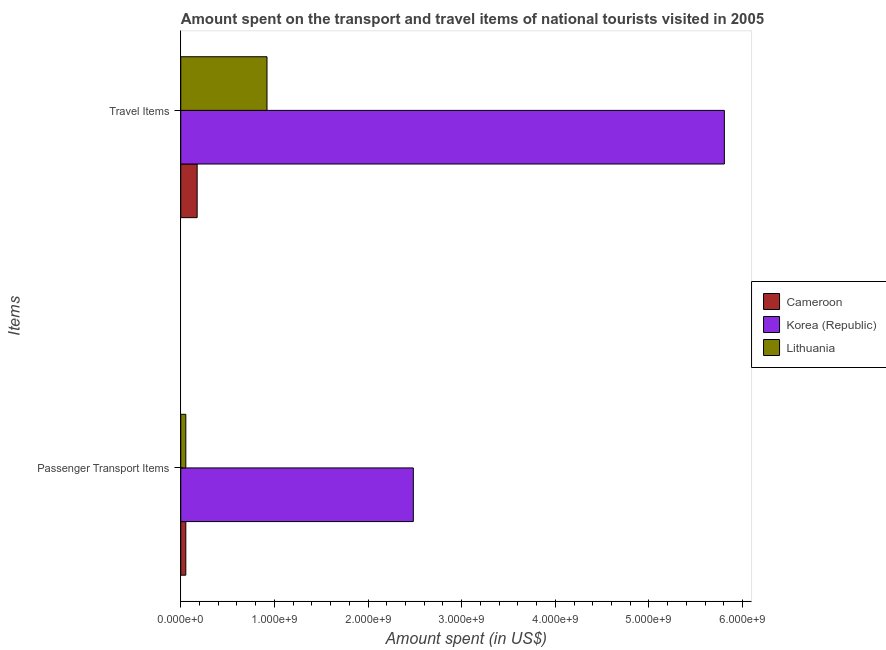How many different coloured bars are there?
Ensure brevity in your answer.  3. How many groups of bars are there?
Make the answer very short. 2. Are the number of bars on each tick of the Y-axis equal?
Keep it short and to the point. Yes. How many bars are there on the 2nd tick from the bottom?
Provide a short and direct response. 3. What is the label of the 1st group of bars from the top?
Provide a succinct answer. Travel Items. What is the amount spent on passenger transport items in Cameroon?
Your response must be concise. 5.40e+07. Across all countries, what is the maximum amount spent in travel items?
Ensure brevity in your answer.  5.81e+09. Across all countries, what is the minimum amount spent on passenger transport items?
Your answer should be compact. 5.40e+07. In which country was the amount spent on passenger transport items maximum?
Give a very brief answer. Korea (Republic). In which country was the amount spent on passenger transport items minimum?
Offer a very short reply. Cameroon. What is the total amount spent on passenger transport items in the graph?
Give a very brief answer. 2.59e+09. What is the difference between the amount spent in travel items in Cameroon and that in Lithuania?
Offer a terse response. -7.46e+08. What is the difference between the amount spent on passenger transport items in Lithuania and the amount spent in travel items in Cameroon?
Ensure brevity in your answer.  -1.21e+08. What is the average amount spent on passenger transport items per country?
Keep it short and to the point. 8.64e+08. What is the difference between the amount spent on passenger transport items and amount spent in travel items in Korea (Republic)?
Your answer should be very brief. -3.32e+09. What is the ratio of the amount spent on passenger transport items in Lithuania to that in Korea (Republic)?
Your answer should be compact. 0.02. In how many countries, is the amount spent on passenger transport items greater than the average amount spent on passenger transport items taken over all countries?
Your response must be concise. 1. What does the 1st bar from the top in Travel Items represents?
Give a very brief answer. Lithuania. What does the 1st bar from the bottom in Passenger Transport Items represents?
Your answer should be very brief. Cameroon. What is the difference between two consecutive major ticks on the X-axis?
Make the answer very short. 1.00e+09. Are the values on the major ticks of X-axis written in scientific E-notation?
Make the answer very short. Yes. Does the graph contain grids?
Give a very brief answer. No. How many legend labels are there?
Give a very brief answer. 3. How are the legend labels stacked?
Provide a short and direct response. Vertical. What is the title of the graph?
Give a very brief answer. Amount spent on the transport and travel items of national tourists visited in 2005. What is the label or title of the X-axis?
Provide a short and direct response. Amount spent (in US$). What is the label or title of the Y-axis?
Your answer should be compact. Items. What is the Amount spent (in US$) of Cameroon in Passenger Transport Items?
Offer a terse response. 5.40e+07. What is the Amount spent (in US$) in Korea (Republic) in Passenger Transport Items?
Make the answer very short. 2.48e+09. What is the Amount spent (in US$) of Lithuania in Passenger Transport Items?
Your answer should be very brief. 5.40e+07. What is the Amount spent (in US$) of Cameroon in Travel Items?
Provide a short and direct response. 1.75e+08. What is the Amount spent (in US$) in Korea (Republic) in Travel Items?
Offer a terse response. 5.81e+09. What is the Amount spent (in US$) of Lithuania in Travel Items?
Keep it short and to the point. 9.21e+08. Across all Items, what is the maximum Amount spent (in US$) in Cameroon?
Keep it short and to the point. 1.75e+08. Across all Items, what is the maximum Amount spent (in US$) of Korea (Republic)?
Your answer should be compact. 5.81e+09. Across all Items, what is the maximum Amount spent (in US$) of Lithuania?
Provide a succinct answer. 9.21e+08. Across all Items, what is the minimum Amount spent (in US$) in Cameroon?
Offer a terse response. 5.40e+07. Across all Items, what is the minimum Amount spent (in US$) of Korea (Republic)?
Your response must be concise. 2.48e+09. Across all Items, what is the minimum Amount spent (in US$) in Lithuania?
Give a very brief answer. 5.40e+07. What is the total Amount spent (in US$) in Cameroon in the graph?
Offer a very short reply. 2.29e+08. What is the total Amount spent (in US$) of Korea (Republic) in the graph?
Your answer should be compact. 8.29e+09. What is the total Amount spent (in US$) in Lithuania in the graph?
Offer a very short reply. 9.75e+08. What is the difference between the Amount spent (in US$) of Cameroon in Passenger Transport Items and that in Travel Items?
Your answer should be very brief. -1.21e+08. What is the difference between the Amount spent (in US$) of Korea (Republic) in Passenger Transport Items and that in Travel Items?
Your answer should be very brief. -3.32e+09. What is the difference between the Amount spent (in US$) in Lithuania in Passenger Transport Items and that in Travel Items?
Offer a terse response. -8.67e+08. What is the difference between the Amount spent (in US$) in Cameroon in Passenger Transport Items and the Amount spent (in US$) in Korea (Republic) in Travel Items?
Keep it short and to the point. -5.75e+09. What is the difference between the Amount spent (in US$) in Cameroon in Passenger Transport Items and the Amount spent (in US$) in Lithuania in Travel Items?
Your response must be concise. -8.67e+08. What is the difference between the Amount spent (in US$) in Korea (Republic) in Passenger Transport Items and the Amount spent (in US$) in Lithuania in Travel Items?
Offer a terse response. 1.56e+09. What is the average Amount spent (in US$) in Cameroon per Items?
Offer a very short reply. 1.14e+08. What is the average Amount spent (in US$) of Korea (Republic) per Items?
Make the answer very short. 4.14e+09. What is the average Amount spent (in US$) in Lithuania per Items?
Offer a terse response. 4.88e+08. What is the difference between the Amount spent (in US$) of Cameroon and Amount spent (in US$) of Korea (Republic) in Passenger Transport Items?
Give a very brief answer. -2.43e+09. What is the difference between the Amount spent (in US$) in Cameroon and Amount spent (in US$) in Lithuania in Passenger Transport Items?
Ensure brevity in your answer.  0. What is the difference between the Amount spent (in US$) in Korea (Republic) and Amount spent (in US$) in Lithuania in Passenger Transport Items?
Ensure brevity in your answer.  2.43e+09. What is the difference between the Amount spent (in US$) in Cameroon and Amount spent (in US$) in Korea (Republic) in Travel Items?
Your answer should be very brief. -5.63e+09. What is the difference between the Amount spent (in US$) of Cameroon and Amount spent (in US$) of Lithuania in Travel Items?
Provide a short and direct response. -7.46e+08. What is the difference between the Amount spent (in US$) in Korea (Republic) and Amount spent (in US$) in Lithuania in Travel Items?
Offer a terse response. 4.88e+09. What is the ratio of the Amount spent (in US$) in Cameroon in Passenger Transport Items to that in Travel Items?
Provide a succinct answer. 0.31. What is the ratio of the Amount spent (in US$) in Korea (Republic) in Passenger Transport Items to that in Travel Items?
Provide a short and direct response. 0.43. What is the ratio of the Amount spent (in US$) of Lithuania in Passenger Transport Items to that in Travel Items?
Ensure brevity in your answer.  0.06. What is the difference between the highest and the second highest Amount spent (in US$) in Cameroon?
Give a very brief answer. 1.21e+08. What is the difference between the highest and the second highest Amount spent (in US$) of Korea (Republic)?
Keep it short and to the point. 3.32e+09. What is the difference between the highest and the second highest Amount spent (in US$) of Lithuania?
Provide a succinct answer. 8.67e+08. What is the difference between the highest and the lowest Amount spent (in US$) in Cameroon?
Make the answer very short. 1.21e+08. What is the difference between the highest and the lowest Amount spent (in US$) of Korea (Republic)?
Your response must be concise. 3.32e+09. What is the difference between the highest and the lowest Amount spent (in US$) of Lithuania?
Offer a terse response. 8.67e+08. 